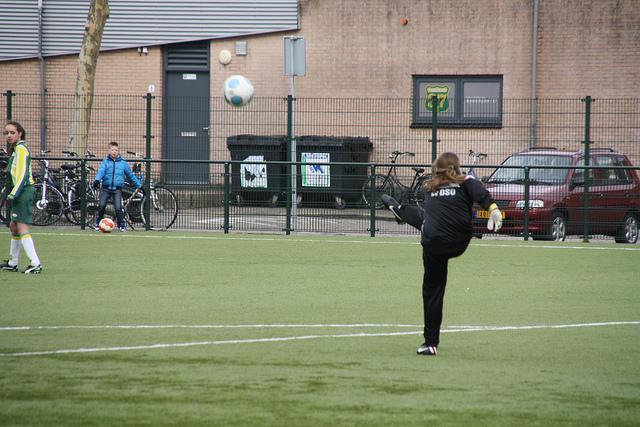How many people are in the photo?
Give a very brief answer. 2. 